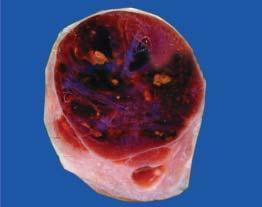what is enlarged diffusely?
Answer the question using a single word or phrase. Thyroid gland 